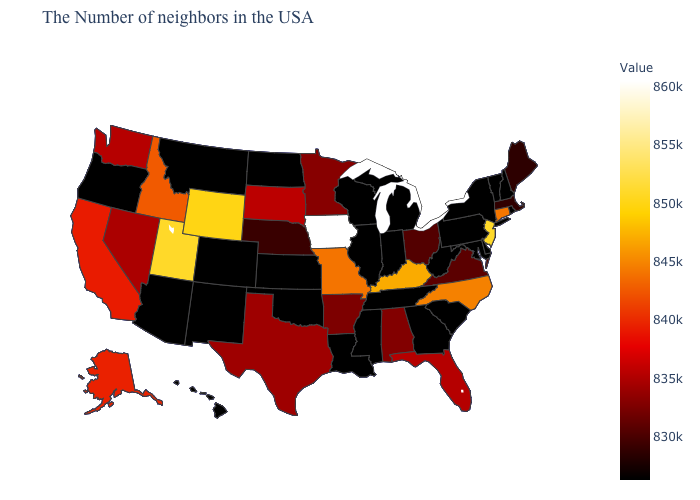Among the states that border Kentucky , which have the lowest value?
Keep it brief. West Virginia, Indiana, Tennessee, Illinois. Which states have the lowest value in the West?
Short answer required. Colorado, New Mexico, Montana, Arizona, Oregon, Hawaii. Among the states that border Texas , does Arkansas have the highest value?
Answer briefly. Yes. Does Louisiana have the highest value in the USA?
Give a very brief answer. No. Is the legend a continuous bar?
Quick response, please. Yes. 